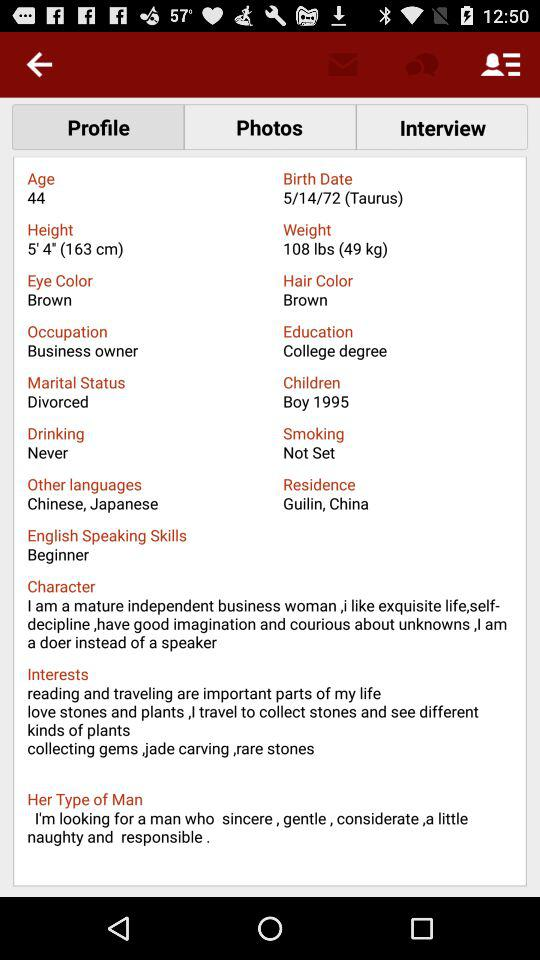Where is the person from? The person is from Guilin, China. 